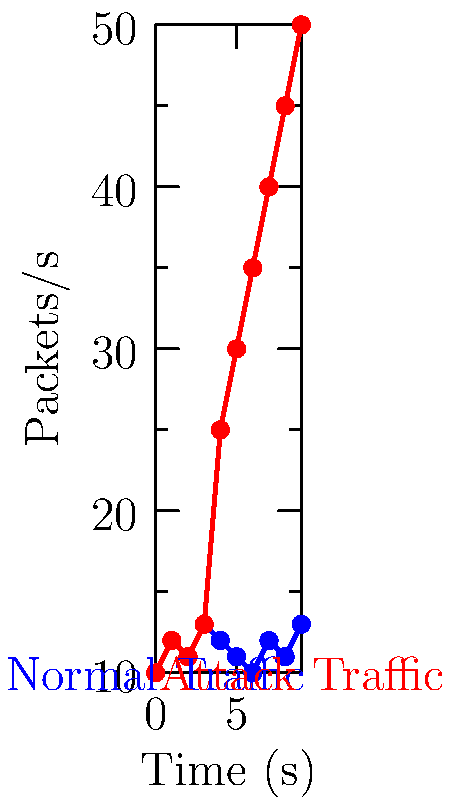As a software engineer engaged in CTF competitions, you're analyzing network traffic patterns. The graph shows packet rates over time for normal traffic (blue) and an attack scenario (red). Which machine learning technique would be most appropriate for detecting this type of network intrusion, and why? To answer this question, let's analyze the graph and consider suitable machine learning techniques:

1. Observe the patterns:
   - Normal traffic (blue) shows consistent, low-amplitude fluctuations.
   - Attack traffic (red) shows a sudden, sustained increase in packet rate.

2. Identify key characteristics:
   - The attack is characterized by an abrupt change in behavior.
   - There's a clear distinction between normal and attack patterns.

3. Consider suitable ML techniques:
   a) Anomaly detection: Ideal for identifying patterns that deviate from the norm.
   b) Time series analysis: Could capture the temporal aspect of the attack.
   c) Classification: Might struggle with the sudden change and lack of labeled data.

4. Evaluate the best option:
   - Anomaly detection, specifically using techniques like Isolation Forest or One-Class SVM, would be most appropriate because:
     i) It can learn the normal behavior pattern.
     ii) It can detect sudden deviations from the norm.
     iii) It doesn't require labeled attack data, which is often scarce in real-world scenarios.

5. Implementation consideration:
   - Features could include rolling statistics (mean, variance) of packet rates.
   - The model could be trained on normal traffic data and set to alert on significant deviations.

Given these factors, anomaly detection emerges as the most suitable technique for this specific network intrusion detection scenario.
Answer: Anomaly detection 